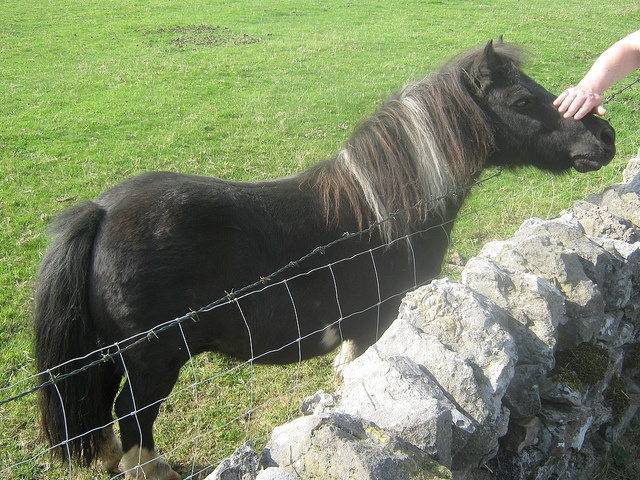Describe the objects in this image and their specific colors. I can see horse in lightgreen, black, gray, darkgray, and darkgreen tones and people in lightgreen, white, darkgray, lightpink, and tan tones in this image. 